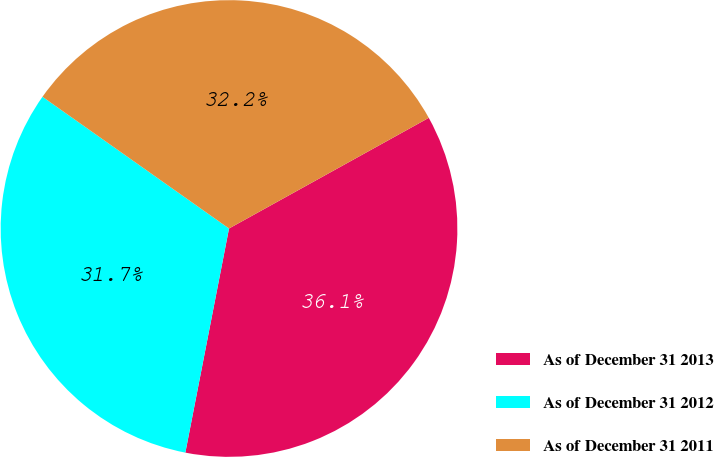<chart> <loc_0><loc_0><loc_500><loc_500><pie_chart><fcel>As of December 31 2013<fcel>As of December 31 2012<fcel>As of December 31 2011<nl><fcel>36.11%<fcel>31.72%<fcel>32.16%<nl></chart> 